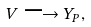Convert formula to latex. <formula><loc_0><loc_0><loc_500><loc_500>V \longrightarrow Y _ { P } ,</formula> 